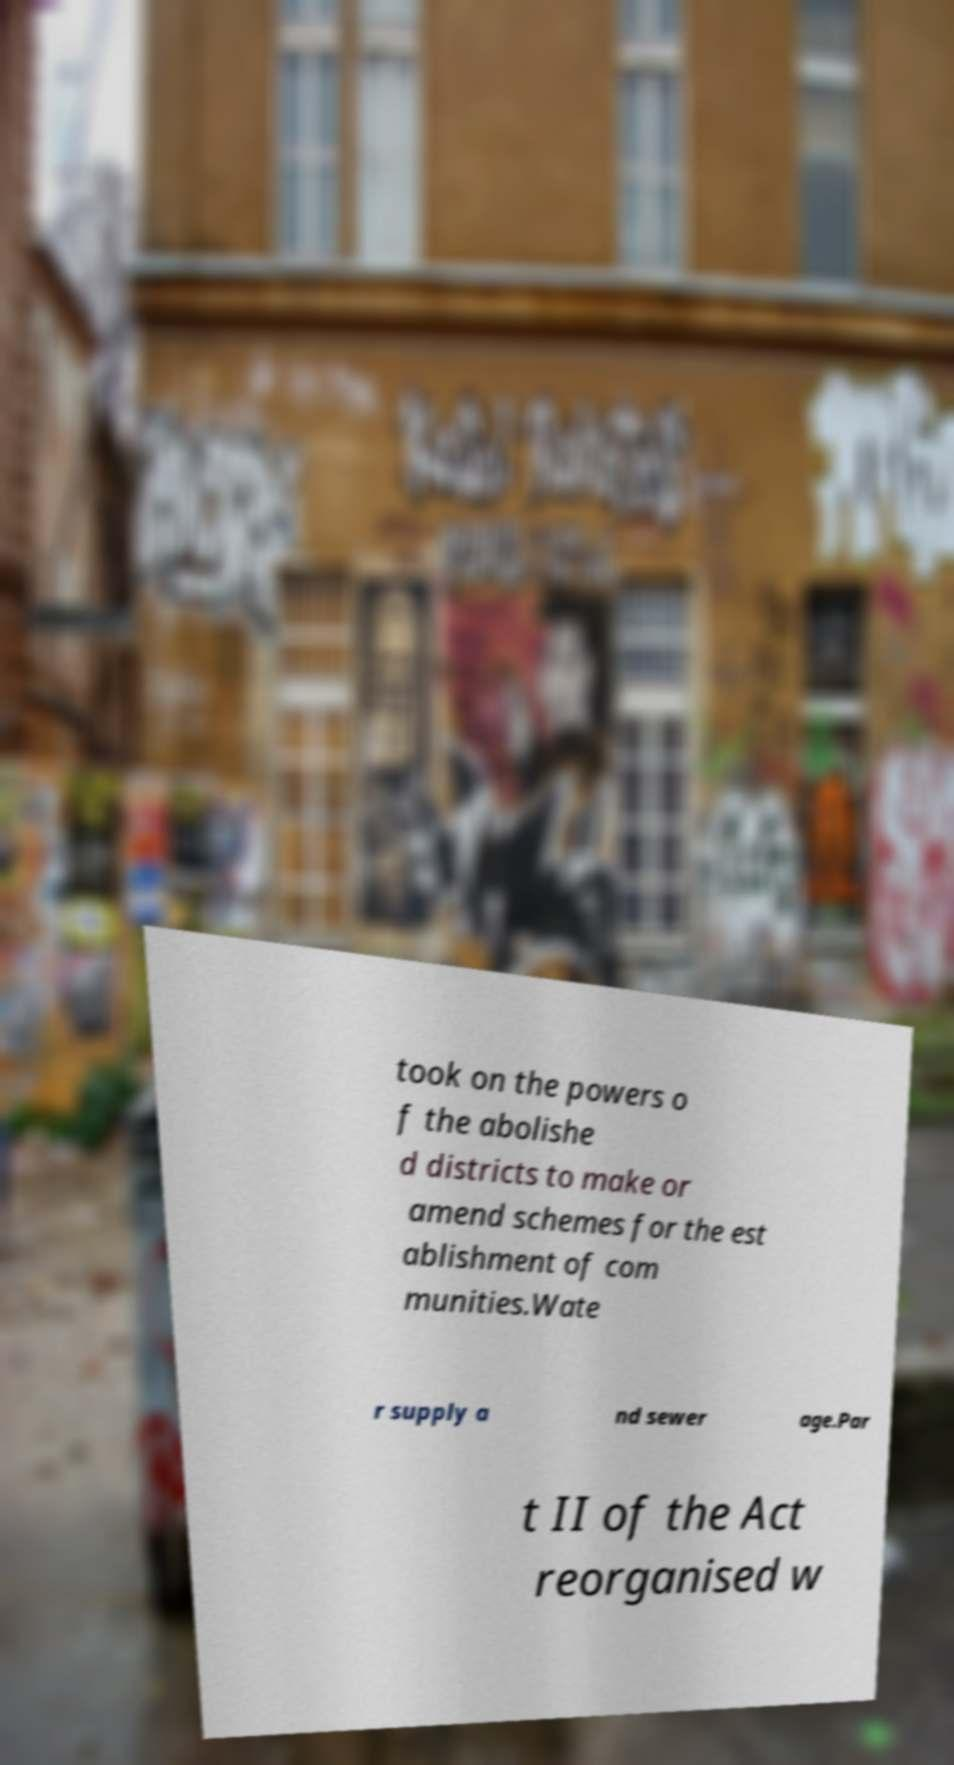What messages or text are displayed in this image? I need them in a readable, typed format. took on the powers o f the abolishe d districts to make or amend schemes for the est ablishment of com munities.Wate r supply a nd sewer age.Par t II of the Act reorganised w 